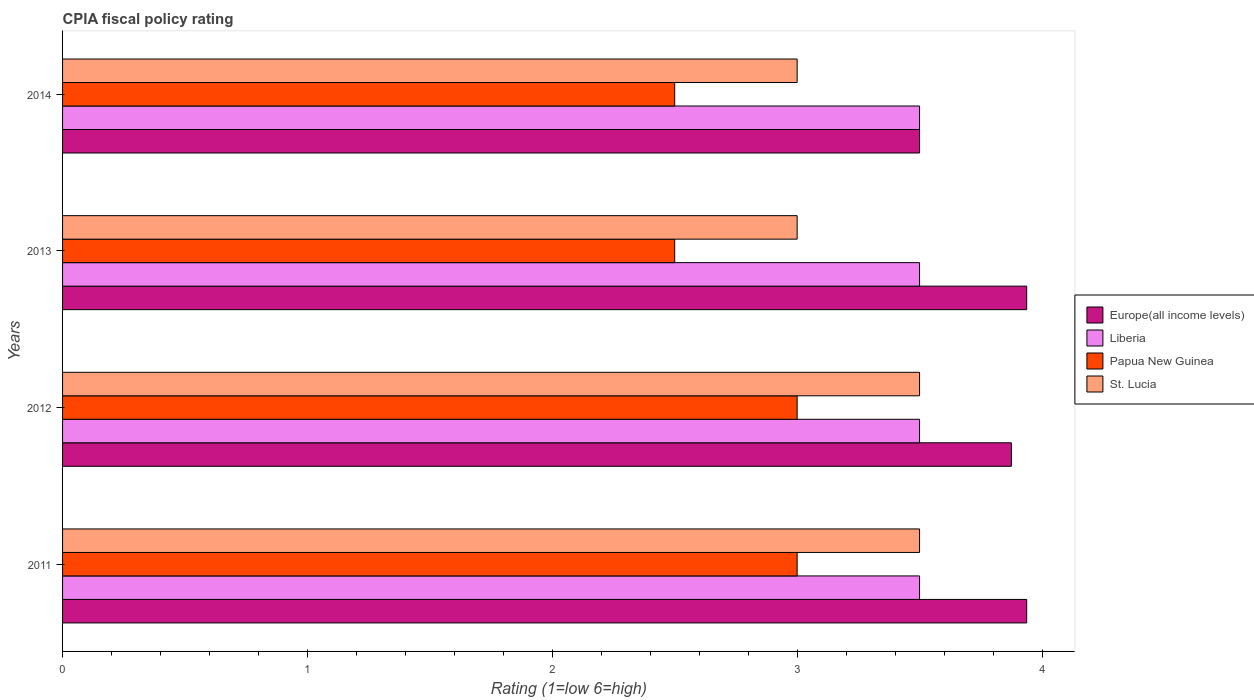How many different coloured bars are there?
Provide a succinct answer. 4. How many groups of bars are there?
Offer a very short reply. 4. Are the number of bars per tick equal to the number of legend labels?
Keep it short and to the point. Yes. How many bars are there on the 2nd tick from the top?
Your answer should be very brief. 4. How many bars are there on the 1st tick from the bottom?
Your response must be concise. 4. In how many cases, is the number of bars for a given year not equal to the number of legend labels?
Provide a succinct answer. 0. Across all years, what is the maximum CPIA rating in Liberia?
Provide a short and direct response. 3.5. Across all years, what is the minimum CPIA rating in Liberia?
Your response must be concise. 3.5. What is the difference between the CPIA rating in Europe(all income levels) in 2012 and that in 2013?
Your answer should be very brief. -0.06. What is the difference between the CPIA rating in Liberia in 2011 and the CPIA rating in Europe(all income levels) in 2014?
Your response must be concise. 0. What is the average CPIA rating in Europe(all income levels) per year?
Offer a terse response. 3.81. In how many years, is the CPIA rating in Liberia greater than 3.2 ?
Offer a terse response. 4. Is the difference between the CPIA rating in Europe(all income levels) in 2012 and 2014 greater than the difference between the CPIA rating in Papua New Guinea in 2012 and 2014?
Provide a succinct answer. No. What is the difference between the highest and the second highest CPIA rating in Liberia?
Give a very brief answer. 0. What is the difference between the highest and the lowest CPIA rating in St. Lucia?
Your response must be concise. 0.5. In how many years, is the CPIA rating in St. Lucia greater than the average CPIA rating in St. Lucia taken over all years?
Ensure brevity in your answer.  2. Is the sum of the CPIA rating in Liberia in 2012 and 2014 greater than the maximum CPIA rating in Europe(all income levels) across all years?
Your answer should be compact. Yes. What does the 3rd bar from the top in 2014 represents?
Offer a terse response. Liberia. What does the 1st bar from the bottom in 2013 represents?
Your answer should be compact. Europe(all income levels). What is the difference between two consecutive major ticks on the X-axis?
Your answer should be very brief. 1. Does the graph contain any zero values?
Keep it short and to the point. No. How many legend labels are there?
Your response must be concise. 4. What is the title of the graph?
Give a very brief answer. CPIA fiscal policy rating. What is the Rating (1=low 6=high) of Europe(all income levels) in 2011?
Make the answer very short. 3.94. What is the Rating (1=low 6=high) in Europe(all income levels) in 2012?
Your answer should be very brief. 3.88. What is the Rating (1=low 6=high) of Liberia in 2012?
Give a very brief answer. 3.5. What is the Rating (1=low 6=high) in Papua New Guinea in 2012?
Your answer should be compact. 3. What is the Rating (1=low 6=high) of Europe(all income levels) in 2013?
Offer a very short reply. 3.94. What is the Rating (1=low 6=high) in Papua New Guinea in 2013?
Offer a very short reply. 2.5. What is the Rating (1=low 6=high) of St. Lucia in 2013?
Your answer should be compact. 3. What is the Rating (1=low 6=high) in Europe(all income levels) in 2014?
Offer a very short reply. 3.5. What is the Rating (1=low 6=high) in Papua New Guinea in 2014?
Give a very brief answer. 2.5. What is the Rating (1=low 6=high) of St. Lucia in 2014?
Give a very brief answer. 3. Across all years, what is the maximum Rating (1=low 6=high) in Europe(all income levels)?
Your response must be concise. 3.94. Across all years, what is the maximum Rating (1=low 6=high) in Liberia?
Provide a short and direct response. 3.5. Across all years, what is the maximum Rating (1=low 6=high) in St. Lucia?
Your response must be concise. 3.5. Across all years, what is the minimum Rating (1=low 6=high) of Europe(all income levels)?
Keep it short and to the point. 3.5. Across all years, what is the minimum Rating (1=low 6=high) in St. Lucia?
Offer a terse response. 3. What is the total Rating (1=low 6=high) in Europe(all income levels) in the graph?
Give a very brief answer. 15.25. What is the total Rating (1=low 6=high) of St. Lucia in the graph?
Provide a succinct answer. 13. What is the difference between the Rating (1=low 6=high) in Europe(all income levels) in 2011 and that in 2012?
Provide a succinct answer. 0.06. What is the difference between the Rating (1=low 6=high) of Papua New Guinea in 2011 and that in 2012?
Keep it short and to the point. 0. What is the difference between the Rating (1=low 6=high) of Liberia in 2011 and that in 2013?
Provide a succinct answer. 0. What is the difference between the Rating (1=low 6=high) of Papua New Guinea in 2011 and that in 2013?
Provide a short and direct response. 0.5. What is the difference between the Rating (1=low 6=high) of St. Lucia in 2011 and that in 2013?
Your answer should be very brief. 0.5. What is the difference between the Rating (1=low 6=high) of Europe(all income levels) in 2011 and that in 2014?
Provide a short and direct response. 0.44. What is the difference between the Rating (1=low 6=high) of Liberia in 2011 and that in 2014?
Your answer should be very brief. 0. What is the difference between the Rating (1=low 6=high) in Europe(all income levels) in 2012 and that in 2013?
Keep it short and to the point. -0.06. What is the difference between the Rating (1=low 6=high) in Liberia in 2012 and that in 2013?
Your answer should be compact. 0. What is the difference between the Rating (1=low 6=high) in Papua New Guinea in 2012 and that in 2013?
Offer a terse response. 0.5. What is the difference between the Rating (1=low 6=high) of St. Lucia in 2012 and that in 2013?
Ensure brevity in your answer.  0.5. What is the difference between the Rating (1=low 6=high) in Europe(all income levels) in 2012 and that in 2014?
Offer a very short reply. 0.38. What is the difference between the Rating (1=low 6=high) of Papua New Guinea in 2012 and that in 2014?
Keep it short and to the point. 0.5. What is the difference between the Rating (1=low 6=high) of St. Lucia in 2012 and that in 2014?
Ensure brevity in your answer.  0.5. What is the difference between the Rating (1=low 6=high) of Europe(all income levels) in 2013 and that in 2014?
Give a very brief answer. 0.44. What is the difference between the Rating (1=low 6=high) of Liberia in 2013 and that in 2014?
Provide a succinct answer. 0. What is the difference between the Rating (1=low 6=high) in Europe(all income levels) in 2011 and the Rating (1=low 6=high) in Liberia in 2012?
Ensure brevity in your answer.  0.44. What is the difference between the Rating (1=low 6=high) of Europe(all income levels) in 2011 and the Rating (1=low 6=high) of St. Lucia in 2012?
Your answer should be compact. 0.44. What is the difference between the Rating (1=low 6=high) of Papua New Guinea in 2011 and the Rating (1=low 6=high) of St. Lucia in 2012?
Your answer should be compact. -0.5. What is the difference between the Rating (1=low 6=high) in Europe(all income levels) in 2011 and the Rating (1=low 6=high) in Liberia in 2013?
Your response must be concise. 0.44. What is the difference between the Rating (1=low 6=high) in Europe(all income levels) in 2011 and the Rating (1=low 6=high) in Papua New Guinea in 2013?
Your answer should be compact. 1.44. What is the difference between the Rating (1=low 6=high) in Liberia in 2011 and the Rating (1=low 6=high) in Papua New Guinea in 2013?
Your answer should be compact. 1. What is the difference between the Rating (1=low 6=high) in Liberia in 2011 and the Rating (1=low 6=high) in St. Lucia in 2013?
Ensure brevity in your answer.  0.5. What is the difference between the Rating (1=low 6=high) of Papua New Guinea in 2011 and the Rating (1=low 6=high) of St. Lucia in 2013?
Your answer should be compact. 0. What is the difference between the Rating (1=low 6=high) in Europe(all income levels) in 2011 and the Rating (1=low 6=high) in Liberia in 2014?
Offer a terse response. 0.44. What is the difference between the Rating (1=low 6=high) in Europe(all income levels) in 2011 and the Rating (1=low 6=high) in Papua New Guinea in 2014?
Offer a very short reply. 1.44. What is the difference between the Rating (1=low 6=high) of Liberia in 2011 and the Rating (1=low 6=high) of Papua New Guinea in 2014?
Your response must be concise. 1. What is the difference between the Rating (1=low 6=high) in Papua New Guinea in 2011 and the Rating (1=low 6=high) in St. Lucia in 2014?
Your answer should be compact. 0. What is the difference between the Rating (1=low 6=high) of Europe(all income levels) in 2012 and the Rating (1=low 6=high) of Papua New Guinea in 2013?
Offer a terse response. 1.38. What is the difference between the Rating (1=low 6=high) of Liberia in 2012 and the Rating (1=low 6=high) of St. Lucia in 2013?
Keep it short and to the point. 0.5. What is the difference between the Rating (1=low 6=high) in Papua New Guinea in 2012 and the Rating (1=low 6=high) in St. Lucia in 2013?
Your answer should be very brief. 0. What is the difference between the Rating (1=low 6=high) in Europe(all income levels) in 2012 and the Rating (1=low 6=high) in Papua New Guinea in 2014?
Your answer should be compact. 1.38. What is the difference between the Rating (1=low 6=high) in Liberia in 2012 and the Rating (1=low 6=high) in Papua New Guinea in 2014?
Provide a succinct answer. 1. What is the difference between the Rating (1=low 6=high) of Liberia in 2012 and the Rating (1=low 6=high) of St. Lucia in 2014?
Your answer should be very brief. 0.5. What is the difference between the Rating (1=low 6=high) in Papua New Guinea in 2012 and the Rating (1=low 6=high) in St. Lucia in 2014?
Offer a terse response. 0. What is the difference between the Rating (1=low 6=high) in Europe(all income levels) in 2013 and the Rating (1=low 6=high) in Liberia in 2014?
Provide a succinct answer. 0.44. What is the difference between the Rating (1=low 6=high) in Europe(all income levels) in 2013 and the Rating (1=low 6=high) in Papua New Guinea in 2014?
Give a very brief answer. 1.44. What is the difference between the Rating (1=low 6=high) in Papua New Guinea in 2013 and the Rating (1=low 6=high) in St. Lucia in 2014?
Ensure brevity in your answer.  -0.5. What is the average Rating (1=low 6=high) of Europe(all income levels) per year?
Your response must be concise. 3.81. What is the average Rating (1=low 6=high) of Liberia per year?
Give a very brief answer. 3.5. What is the average Rating (1=low 6=high) in Papua New Guinea per year?
Your answer should be compact. 2.75. In the year 2011, what is the difference between the Rating (1=low 6=high) in Europe(all income levels) and Rating (1=low 6=high) in Liberia?
Your answer should be very brief. 0.44. In the year 2011, what is the difference between the Rating (1=low 6=high) of Europe(all income levels) and Rating (1=low 6=high) of St. Lucia?
Offer a terse response. 0.44. In the year 2011, what is the difference between the Rating (1=low 6=high) of Liberia and Rating (1=low 6=high) of Papua New Guinea?
Your answer should be very brief. 0.5. In the year 2011, what is the difference between the Rating (1=low 6=high) in Liberia and Rating (1=low 6=high) in St. Lucia?
Provide a succinct answer. 0. In the year 2011, what is the difference between the Rating (1=low 6=high) in Papua New Guinea and Rating (1=low 6=high) in St. Lucia?
Keep it short and to the point. -0.5. In the year 2012, what is the difference between the Rating (1=low 6=high) in Europe(all income levels) and Rating (1=low 6=high) in Papua New Guinea?
Give a very brief answer. 0.88. In the year 2012, what is the difference between the Rating (1=low 6=high) in Europe(all income levels) and Rating (1=low 6=high) in St. Lucia?
Provide a succinct answer. 0.38. In the year 2013, what is the difference between the Rating (1=low 6=high) in Europe(all income levels) and Rating (1=low 6=high) in Liberia?
Offer a terse response. 0.44. In the year 2013, what is the difference between the Rating (1=low 6=high) in Europe(all income levels) and Rating (1=low 6=high) in Papua New Guinea?
Your answer should be very brief. 1.44. In the year 2013, what is the difference between the Rating (1=low 6=high) in Europe(all income levels) and Rating (1=low 6=high) in St. Lucia?
Make the answer very short. 0.94. In the year 2013, what is the difference between the Rating (1=low 6=high) in Papua New Guinea and Rating (1=low 6=high) in St. Lucia?
Your answer should be compact. -0.5. In the year 2014, what is the difference between the Rating (1=low 6=high) in Europe(all income levels) and Rating (1=low 6=high) in Liberia?
Provide a short and direct response. 0. In the year 2014, what is the difference between the Rating (1=low 6=high) in Europe(all income levels) and Rating (1=low 6=high) in Papua New Guinea?
Offer a terse response. 1. In the year 2014, what is the difference between the Rating (1=low 6=high) of Europe(all income levels) and Rating (1=low 6=high) of St. Lucia?
Offer a very short reply. 0.5. In the year 2014, what is the difference between the Rating (1=low 6=high) in Liberia and Rating (1=low 6=high) in Papua New Guinea?
Make the answer very short. 1. What is the ratio of the Rating (1=low 6=high) in Europe(all income levels) in 2011 to that in 2012?
Your response must be concise. 1.02. What is the ratio of the Rating (1=low 6=high) of Papua New Guinea in 2011 to that in 2013?
Provide a short and direct response. 1.2. What is the ratio of the Rating (1=low 6=high) of St. Lucia in 2011 to that in 2013?
Provide a succinct answer. 1.17. What is the ratio of the Rating (1=low 6=high) in Europe(all income levels) in 2011 to that in 2014?
Provide a succinct answer. 1.12. What is the ratio of the Rating (1=low 6=high) of Papua New Guinea in 2011 to that in 2014?
Provide a succinct answer. 1.2. What is the ratio of the Rating (1=low 6=high) of St. Lucia in 2011 to that in 2014?
Keep it short and to the point. 1.17. What is the ratio of the Rating (1=low 6=high) of Europe(all income levels) in 2012 to that in 2013?
Ensure brevity in your answer.  0.98. What is the ratio of the Rating (1=low 6=high) of St. Lucia in 2012 to that in 2013?
Your answer should be very brief. 1.17. What is the ratio of the Rating (1=low 6=high) in Europe(all income levels) in 2012 to that in 2014?
Your answer should be very brief. 1.11. What is the ratio of the Rating (1=low 6=high) of Liberia in 2012 to that in 2014?
Provide a succinct answer. 1. What is the ratio of the Rating (1=low 6=high) of Liberia in 2013 to that in 2014?
Ensure brevity in your answer.  1. What is the ratio of the Rating (1=low 6=high) in St. Lucia in 2013 to that in 2014?
Provide a succinct answer. 1. What is the difference between the highest and the second highest Rating (1=low 6=high) in Europe(all income levels)?
Make the answer very short. 0. What is the difference between the highest and the lowest Rating (1=low 6=high) of Europe(all income levels)?
Give a very brief answer. 0.44. What is the difference between the highest and the lowest Rating (1=low 6=high) of Papua New Guinea?
Give a very brief answer. 0.5. 